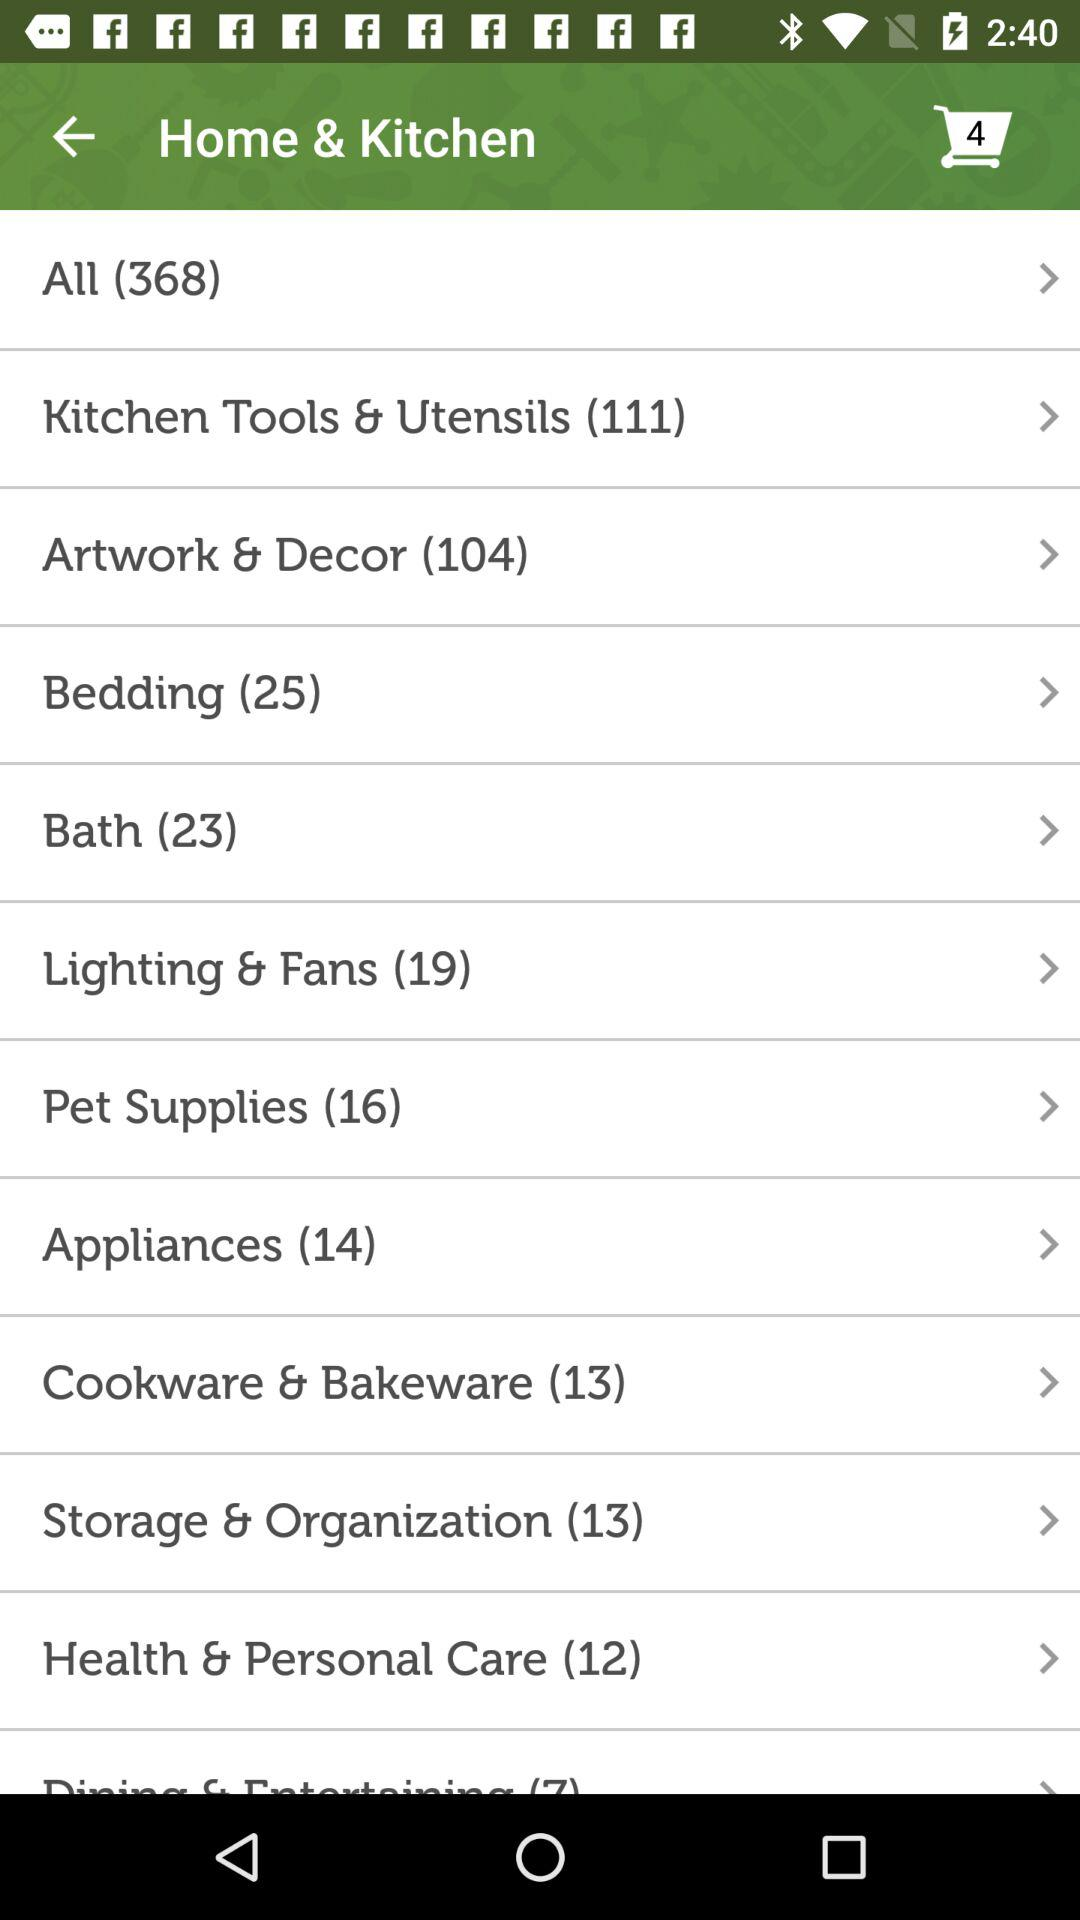How many items in total are there in the "Appliances" category? There are 14 items in total in the "Appliances" category. 